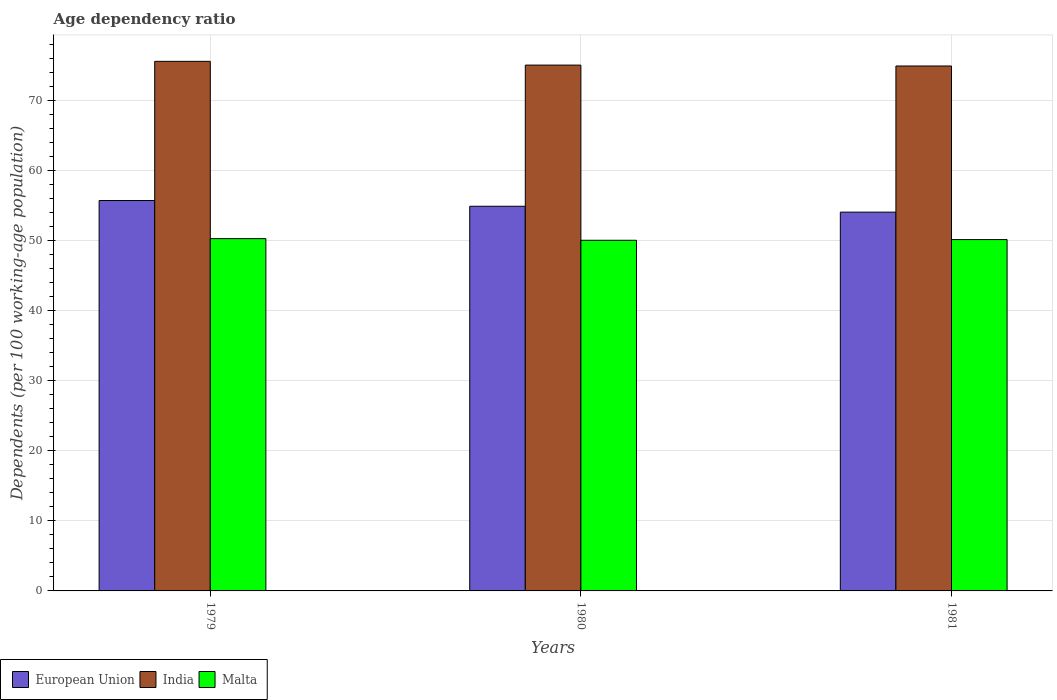How many different coloured bars are there?
Your answer should be very brief. 3. How many bars are there on the 1st tick from the left?
Ensure brevity in your answer.  3. How many bars are there on the 3rd tick from the right?
Provide a succinct answer. 3. What is the label of the 1st group of bars from the left?
Offer a terse response. 1979. What is the age dependency ratio in in European Union in 1979?
Provide a succinct answer. 55.73. Across all years, what is the maximum age dependency ratio in in Malta?
Provide a short and direct response. 50.29. Across all years, what is the minimum age dependency ratio in in India?
Your answer should be compact. 74.93. In which year was the age dependency ratio in in European Union maximum?
Ensure brevity in your answer.  1979. What is the total age dependency ratio in in European Union in the graph?
Offer a terse response. 164.71. What is the difference between the age dependency ratio in in European Union in 1980 and that in 1981?
Provide a succinct answer. 0.84. What is the difference between the age dependency ratio in in India in 1981 and the age dependency ratio in in European Union in 1980?
Provide a short and direct response. 20.02. What is the average age dependency ratio in in Malta per year?
Provide a short and direct response. 50.17. In the year 1981, what is the difference between the age dependency ratio in in European Union and age dependency ratio in in Malta?
Your response must be concise. 3.92. What is the ratio of the age dependency ratio in in Malta in 1979 to that in 1981?
Provide a short and direct response. 1. Is the age dependency ratio in in India in 1979 less than that in 1980?
Your answer should be compact. No. Is the difference between the age dependency ratio in in European Union in 1979 and 1980 greater than the difference between the age dependency ratio in in Malta in 1979 and 1980?
Provide a succinct answer. Yes. What is the difference between the highest and the second highest age dependency ratio in in India?
Provide a short and direct response. 0.54. What is the difference between the highest and the lowest age dependency ratio in in European Union?
Keep it short and to the point. 1.66. In how many years, is the age dependency ratio in in European Union greater than the average age dependency ratio in in European Union taken over all years?
Offer a very short reply. 2. Is the sum of the age dependency ratio in in European Union in 1980 and 1981 greater than the maximum age dependency ratio in in India across all years?
Ensure brevity in your answer.  Yes. What does the 1st bar from the left in 1979 represents?
Keep it short and to the point. European Union. How many bars are there?
Offer a terse response. 9. Are all the bars in the graph horizontal?
Offer a very short reply. No. How many years are there in the graph?
Provide a succinct answer. 3. What is the difference between two consecutive major ticks on the Y-axis?
Offer a terse response. 10. Where does the legend appear in the graph?
Offer a very short reply. Bottom left. How many legend labels are there?
Your response must be concise. 3. What is the title of the graph?
Your answer should be compact. Age dependency ratio. What is the label or title of the X-axis?
Ensure brevity in your answer.  Years. What is the label or title of the Y-axis?
Your response must be concise. Dependents (per 100 working-age population). What is the Dependents (per 100 working-age population) of European Union in 1979?
Offer a very short reply. 55.73. What is the Dependents (per 100 working-age population) of India in 1979?
Keep it short and to the point. 75.59. What is the Dependents (per 100 working-age population) of Malta in 1979?
Provide a succinct answer. 50.29. What is the Dependents (per 100 working-age population) in European Union in 1980?
Make the answer very short. 54.91. What is the Dependents (per 100 working-age population) of India in 1980?
Your answer should be very brief. 75.06. What is the Dependents (per 100 working-age population) in Malta in 1980?
Ensure brevity in your answer.  50.05. What is the Dependents (per 100 working-age population) in European Union in 1981?
Offer a terse response. 54.07. What is the Dependents (per 100 working-age population) in India in 1981?
Keep it short and to the point. 74.93. What is the Dependents (per 100 working-age population) of Malta in 1981?
Provide a short and direct response. 50.15. Across all years, what is the maximum Dependents (per 100 working-age population) in European Union?
Your response must be concise. 55.73. Across all years, what is the maximum Dependents (per 100 working-age population) of India?
Keep it short and to the point. 75.59. Across all years, what is the maximum Dependents (per 100 working-age population) in Malta?
Offer a very short reply. 50.29. Across all years, what is the minimum Dependents (per 100 working-age population) in European Union?
Keep it short and to the point. 54.07. Across all years, what is the minimum Dependents (per 100 working-age population) in India?
Your answer should be very brief. 74.93. Across all years, what is the minimum Dependents (per 100 working-age population) in Malta?
Provide a short and direct response. 50.05. What is the total Dependents (per 100 working-age population) in European Union in the graph?
Your answer should be compact. 164.71. What is the total Dependents (per 100 working-age population) of India in the graph?
Your answer should be compact. 225.58. What is the total Dependents (per 100 working-age population) in Malta in the graph?
Make the answer very short. 150.5. What is the difference between the Dependents (per 100 working-age population) of European Union in 1979 and that in 1980?
Offer a terse response. 0.82. What is the difference between the Dependents (per 100 working-age population) in India in 1979 and that in 1980?
Provide a succinct answer. 0.54. What is the difference between the Dependents (per 100 working-age population) of Malta in 1979 and that in 1980?
Your answer should be very brief. 0.24. What is the difference between the Dependents (per 100 working-age population) of European Union in 1979 and that in 1981?
Provide a short and direct response. 1.66. What is the difference between the Dependents (per 100 working-age population) of India in 1979 and that in 1981?
Ensure brevity in your answer.  0.66. What is the difference between the Dependents (per 100 working-age population) of Malta in 1979 and that in 1981?
Your response must be concise. 0.14. What is the difference between the Dependents (per 100 working-age population) of European Union in 1980 and that in 1981?
Give a very brief answer. 0.84. What is the difference between the Dependents (per 100 working-age population) in India in 1980 and that in 1981?
Provide a succinct answer. 0.13. What is the difference between the Dependents (per 100 working-age population) in Malta in 1980 and that in 1981?
Provide a succinct answer. -0.1. What is the difference between the Dependents (per 100 working-age population) of European Union in 1979 and the Dependents (per 100 working-age population) of India in 1980?
Make the answer very short. -19.33. What is the difference between the Dependents (per 100 working-age population) of European Union in 1979 and the Dependents (per 100 working-age population) of Malta in 1980?
Your answer should be very brief. 5.68. What is the difference between the Dependents (per 100 working-age population) in India in 1979 and the Dependents (per 100 working-age population) in Malta in 1980?
Ensure brevity in your answer.  25.54. What is the difference between the Dependents (per 100 working-age population) of European Union in 1979 and the Dependents (per 100 working-age population) of India in 1981?
Provide a succinct answer. -19.2. What is the difference between the Dependents (per 100 working-age population) in European Union in 1979 and the Dependents (per 100 working-age population) in Malta in 1981?
Provide a short and direct response. 5.58. What is the difference between the Dependents (per 100 working-age population) in India in 1979 and the Dependents (per 100 working-age population) in Malta in 1981?
Ensure brevity in your answer.  25.44. What is the difference between the Dependents (per 100 working-age population) of European Union in 1980 and the Dependents (per 100 working-age population) of India in 1981?
Your answer should be compact. -20.02. What is the difference between the Dependents (per 100 working-age population) of European Union in 1980 and the Dependents (per 100 working-age population) of Malta in 1981?
Keep it short and to the point. 4.76. What is the difference between the Dependents (per 100 working-age population) of India in 1980 and the Dependents (per 100 working-age population) of Malta in 1981?
Make the answer very short. 24.9. What is the average Dependents (per 100 working-age population) in European Union per year?
Provide a succinct answer. 54.9. What is the average Dependents (per 100 working-age population) of India per year?
Offer a very short reply. 75.19. What is the average Dependents (per 100 working-age population) of Malta per year?
Give a very brief answer. 50.17. In the year 1979, what is the difference between the Dependents (per 100 working-age population) in European Union and Dependents (per 100 working-age population) in India?
Offer a very short reply. -19.86. In the year 1979, what is the difference between the Dependents (per 100 working-age population) of European Union and Dependents (per 100 working-age population) of Malta?
Give a very brief answer. 5.44. In the year 1979, what is the difference between the Dependents (per 100 working-age population) in India and Dependents (per 100 working-age population) in Malta?
Provide a succinct answer. 25.31. In the year 1980, what is the difference between the Dependents (per 100 working-age population) in European Union and Dependents (per 100 working-age population) in India?
Your response must be concise. -20.15. In the year 1980, what is the difference between the Dependents (per 100 working-age population) in European Union and Dependents (per 100 working-age population) in Malta?
Your answer should be compact. 4.86. In the year 1980, what is the difference between the Dependents (per 100 working-age population) of India and Dependents (per 100 working-age population) of Malta?
Provide a short and direct response. 25. In the year 1981, what is the difference between the Dependents (per 100 working-age population) in European Union and Dependents (per 100 working-age population) in India?
Provide a succinct answer. -20.86. In the year 1981, what is the difference between the Dependents (per 100 working-age population) in European Union and Dependents (per 100 working-age population) in Malta?
Offer a very short reply. 3.92. In the year 1981, what is the difference between the Dependents (per 100 working-age population) of India and Dependents (per 100 working-age population) of Malta?
Provide a succinct answer. 24.78. What is the ratio of the Dependents (per 100 working-age population) of India in 1979 to that in 1980?
Your answer should be compact. 1.01. What is the ratio of the Dependents (per 100 working-age population) of Malta in 1979 to that in 1980?
Keep it short and to the point. 1. What is the ratio of the Dependents (per 100 working-age population) in European Union in 1979 to that in 1981?
Make the answer very short. 1.03. What is the ratio of the Dependents (per 100 working-age population) in India in 1979 to that in 1981?
Offer a very short reply. 1.01. What is the ratio of the Dependents (per 100 working-age population) in Malta in 1979 to that in 1981?
Provide a succinct answer. 1. What is the ratio of the Dependents (per 100 working-age population) of European Union in 1980 to that in 1981?
Offer a very short reply. 1.02. What is the ratio of the Dependents (per 100 working-age population) in Malta in 1980 to that in 1981?
Ensure brevity in your answer.  1. What is the difference between the highest and the second highest Dependents (per 100 working-age population) of European Union?
Keep it short and to the point. 0.82. What is the difference between the highest and the second highest Dependents (per 100 working-age population) in India?
Give a very brief answer. 0.54. What is the difference between the highest and the second highest Dependents (per 100 working-age population) in Malta?
Make the answer very short. 0.14. What is the difference between the highest and the lowest Dependents (per 100 working-age population) in European Union?
Give a very brief answer. 1.66. What is the difference between the highest and the lowest Dependents (per 100 working-age population) of India?
Your response must be concise. 0.66. What is the difference between the highest and the lowest Dependents (per 100 working-age population) in Malta?
Provide a short and direct response. 0.24. 